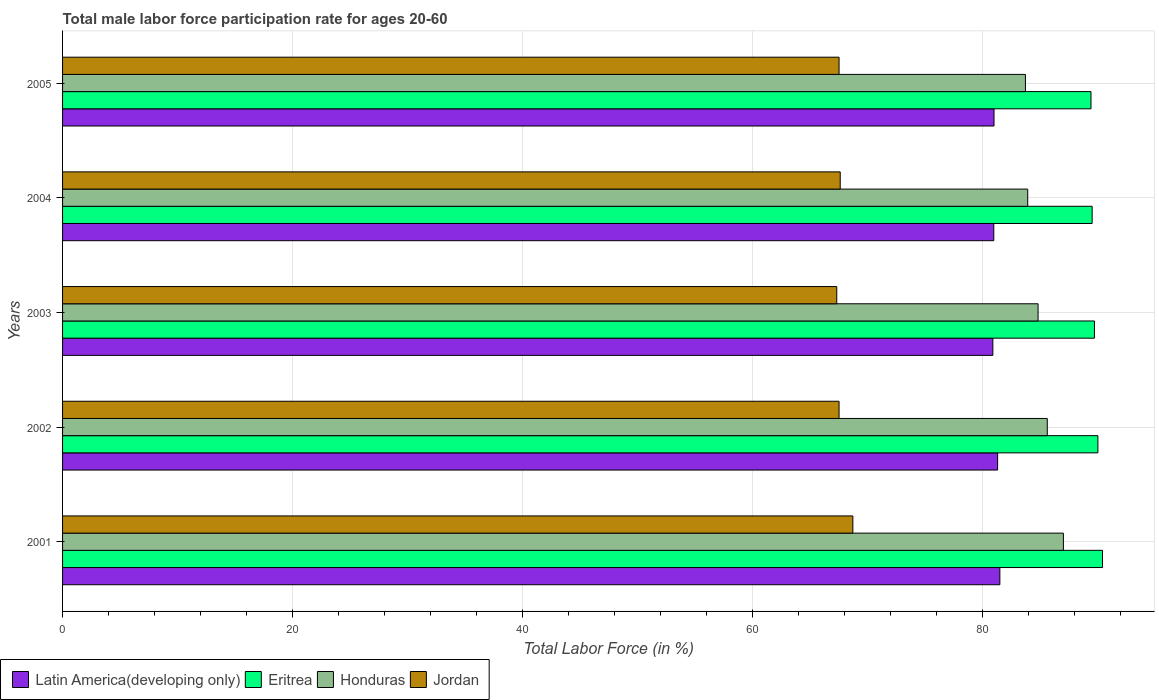How many different coloured bars are there?
Your answer should be compact. 4. How many bars are there on the 3rd tick from the top?
Make the answer very short. 4. How many bars are there on the 4th tick from the bottom?
Offer a very short reply. 4. What is the label of the 1st group of bars from the top?
Provide a succinct answer. 2005. In how many cases, is the number of bars for a given year not equal to the number of legend labels?
Offer a very short reply. 0. What is the male labor force participation rate in Eritrea in 2003?
Keep it short and to the point. 89.7. Across all years, what is the maximum male labor force participation rate in Latin America(developing only)?
Your answer should be very brief. 81.48. Across all years, what is the minimum male labor force participation rate in Latin America(developing only)?
Keep it short and to the point. 80.87. In which year was the male labor force participation rate in Jordan minimum?
Your response must be concise. 2003. What is the total male labor force participation rate in Eritrea in the graph?
Offer a very short reply. 449. What is the difference between the male labor force participation rate in Latin America(developing only) in 2001 and that in 2002?
Give a very brief answer. 0.19. What is the average male labor force participation rate in Honduras per year?
Provide a succinct answer. 85. In the year 2005, what is the difference between the male labor force participation rate in Eritrea and male labor force participation rate in Jordan?
Your response must be concise. 21.9. In how many years, is the male labor force participation rate in Eritrea greater than 64 %?
Give a very brief answer. 5. What is the ratio of the male labor force participation rate in Latin America(developing only) in 2001 to that in 2004?
Ensure brevity in your answer.  1.01. Is the male labor force participation rate in Eritrea in 2002 less than that in 2005?
Make the answer very short. No. Is the difference between the male labor force participation rate in Eritrea in 2002 and 2005 greater than the difference between the male labor force participation rate in Jordan in 2002 and 2005?
Give a very brief answer. Yes. What is the difference between the highest and the second highest male labor force participation rate in Latin America(developing only)?
Provide a short and direct response. 0.19. What is the difference between the highest and the lowest male labor force participation rate in Latin America(developing only)?
Ensure brevity in your answer.  0.61. In how many years, is the male labor force participation rate in Honduras greater than the average male labor force participation rate in Honduras taken over all years?
Your answer should be very brief. 2. Is the sum of the male labor force participation rate in Latin America(developing only) in 2001 and 2004 greater than the maximum male labor force participation rate in Eritrea across all years?
Ensure brevity in your answer.  Yes. Is it the case that in every year, the sum of the male labor force participation rate in Jordan and male labor force participation rate in Eritrea is greater than the sum of male labor force participation rate in Latin America(developing only) and male labor force participation rate in Honduras?
Your answer should be very brief. Yes. What does the 1st bar from the top in 2005 represents?
Offer a very short reply. Jordan. What does the 2nd bar from the bottom in 2004 represents?
Keep it short and to the point. Eritrea. Are all the bars in the graph horizontal?
Offer a terse response. Yes. What is the difference between two consecutive major ticks on the X-axis?
Ensure brevity in your answer.  20. Are the values on the major ticks of X-axis written in scientific E-notation?
Offer a very short reply. No. Where does the legend appear in the graph?
Provide a short and direct response. Bottom left. How many legend labels are there?
Your answer should be compact. 4. How are the legend labels stacked?
Give a very brief answer. Horizontal. What is the title of the graph?
Offer a very short reply. Total male labor force participation rate for ages 20-60. What is the Total Labor Force (in %) of Latin America(developing only) in 2001?
Keep it short and to the point. 81.48. What is the Total Labor Force (in %) in Eritrea in 2001?
Give a very brief answer. 90.4. What is the Total Labor Force (in %) in Honduras in 2001?
Your answer should be compact. 87. What is the Total Labor Force (in %) in Jordan in 2001?
Make the answer very short. 68.7. What is the Total Labor Force (in %) of Latin America(developing only) in 2002?
Make the answer very short. 81.28. What is the Total Labor Force (in %) in Honduras in 2002?
Make the answer very short. 85.6. What is the Total Labor Force (in %) of Jordan in 2002?
Make the answer very short. 67.5. What is the Total Labor Force (in %) of Latin America(developing only) in 2003?
Keep it short and to the point. 80.87. What is the Total Labor Force (in %) in Eritrea in 2003?
Your answer should be very brief. 89.7. What is the Total Labor Force (in %) in Honduras in 2003?
Offer a very short reply. 84.8. What is the Total Labor Force (in %) of Jordan in 2003?
Ensure brevity in your answer.  67.3. What is the Total Labor Force (in %) of Latin America(developing only) in 2004?
Offer a very short reply. 80.95. What is the Total Labor Force (in %) of Eritrea in 2004?
Keep it short and to the point. 89.5. What is the Total Labor Force (in %) of Honduras in 2004?
Give a very brief answer. 83.9. What is the Total Labor Force (in %) of Jordan in 2004?
Ensure brevity in your answer.  67.6. What is the Total Labor Force (in %) in Latin America(developing only) in 2005?
Give a very brief answer. 80.97. What is the Total Labor Force (in %) of Eritrea in 2005?
Your answer should be compact. 89.4. What is the Total Labor Force (in %) in Honduras in 2005?
Ensure brevity in your answer.  83.7. What is the Total Labor Force (in %) of Jordan in 2005?
Give a very brief answer. 67.5. Across all years, what is the maximum Total Labor Force (in %) in Latin America(developing only)?
Your answer should be compact. 81.48. Across all years, what is the maximum Total Labor Force (in %) in Eritrea?
Make the answer very short. 90.4. Across all years, what is the maximum Total Labor Force (in %) in Honduras?
Offer a very short reply. 87. Across all years, what is the maximum Total Labor Force (in %) of Jordan?
Make the answer very short. 68.7. Across all years, what is the minimum Total Labor Force (in %) of Latin America(developing only)?
Provide a short and direct response. 80.87. Across all years, what is the minimum Total Labor Force (in %) in Eritrea?
Give a very brief answer. 89.4. Across all years, what is the minimum Total Labor Force (in %) of Honduras?
Your answer should be very brief. 83.7. Across all years, what is the minimum Total Labor Force (in %) of Jordan?
Keep it short and to the point. 67.3. What is the total Total Labor Force (in %) of Latin America(developing only) in the graph?
Offer a terse response. 405.55. What is the total Total Labor Force (in %) in Eritrea in the graph?
Your answer should be compact. 449. What is the total Total Labor Force (in %) of Honduras in the graph?
Give a very brief answer. 425. What is the total Total Labor Force (in %) of Jordan in the graph?
Ensure brevity in your answer.  338.6. What is the difference between the Total Labor Force (in %) in Latin America(developing only) in 2001 and that in 2002?
Give a very brief answer. 0.19. What is the difference between the Total Labor Force (in %) in Honduras in 2001 and that in 2002?
Provide a succinct answer. 1.4. What is the difference between the Total Labor Force (in %) of Jordan in 2001 and that in 2002?
Ensure brevity in your answer.  1.2. What is the difference between the Total Labor Force (in %) of Latin America(developing only) in 2001 and that in 2003?
Offer a terse response. 0.61. What is the difference between the Total Labor Force (in %) of Eritrea in 2001 and that in 2003?
Keep it short and to the point. 0.7. What is the difference between the Total Labor Force (in %) of Jordan in 2001 and that in 2003?
Ensure brevity in your answer.  1.4. What is the difference between the Total Labor Force (in %) of Latin America(developing only) in 2001 and that in 2004?
Your answer should be compact. 0.53. What is the difference between the Total Labor Force (in %) in Honduras in 2001 and that in 2004?
Provide a succinct answer. 3.1. What is the difference between the Total Labor Force (in %) of Latin America(developing only) in 2001 and that in 2005?
Your answer should be very brief. 0.51. What is the difference between the Total Labor Force (in %) of Latin America(developing only) in 2002 and that in 2003?
Give a very brief answer. 0.41. What is the difference between the Total Labor Force (in %) of Latin America(developing only) in 2002 and that in 2004?
Ensure brevity in your answer.  0.33. What is the difference between the Total Labor Force (in %) of Eritrea in 2002 and that in 2004?
Provide a short and direct response. 0.5. What is the difference between the Total Labor Force (in %) of Jordan in 2002 and that in 2004?
Your answer should be very brief. -0.1. What is the difference between the Total Labor Force (in %) of Latin America(developing only) in 2002 and that in 2005?
Offer a terse response. 0.31. What is the difference between the Total Labor Force (in %) in Honduras in 2002 and that in 2005?
Provide a short and direct response. 1.9. What is the difference between the Total Labor Force (in %) of Latin America(developing only) in 2003 and that in 2004?
Offer a very short reply. -0.08. What is the difference between the Total Labor Force (in %) of Latin America(developing only) in 2003 and that in 2005?
Your response must be concise. -0.1. What is the difference between the Total Labor Force (in %) of Eritrea in 2003 and that in 2005?
Ensure brevity in your answer.  0.3. What is the difference between the Total Labor Force (in %) in Jordan in 2003 and that in 2005?
Your response must be concise. -0.2. What is the difference between the Total Labor Force (in %) of Latin America(developing only) in 2004 and that in 2005?
Give a very brief answer. -0.02. What is the difference between the Total Labor Force (in %) in Latin America(developing only) in 2001 and the Total Labor Force (in %) in Eritrea in 2002?
Your answer should be very brief. -8.52. What is the difference between the Total Labor Force (in %) in Latin America(developing only) in 2001 and the Total Labor Force (in %) in Honduras in 2002?
Provide a short and direct response. -4.12. What is the difference between the Total Labor Force (in %) of Latin America(developing only) in 2001 and the Total Labor Force (in %) of Jordan in 2002?
Ensure brevity in your answer.  13.98. What is the difference between the Total Labor Force (in %) of Eritrea in 2001 and the Total Labor Force (in %) of Honduras in 2002?
Make the answer very short. 4.8. What is the difference between the Total Labor Force (in %) of Eritrea in 2001 and the Total Labor Force (in %) of Jordan in 2002?
Your response must be concise. 22.9. What is the difference between the Total Labor Force (in %) of Honduras in 2001 and the Total Labor Force (in %) of Jordan in 2002?
Give a very brief answer. 19.5. What is the difference between the Total Labor Force (in %) in Latin America(developing only) in 2001 and the Total Labor Force (in %) in Eritrea in 2003?
Your response must be concise. -8.22. What is the difference between the Total Labor Force (in %) in Latin America(developing only) in 2001 and the Total Labor Force (in %) in Honduras in 2003?
Offer a terse response. -3.32. What is the difference between the Total Labor Force (in %) of Latin America(developing only) in 2001 and the Total Labor Force (in %) of Jordan in 2003?
Keep it short and to the point. 14.18. What is the difference between the Total Labor Force (in %) in Eritrea in 2001 and the Total Labor Force (in %) in Jordan in 2003?
Your answer should be compact. 23.1. What is the difference between the Total Labor Force (in %) of Latin America(developing only) in 2001 and the Total Labor Force (in %) of Eritrea in 2004?
Give a very brief answer. -8.02. What is the difference between the Total Labor Force (in %) in Latin America(developing only) in 2001 and the Total Labor Force (in %) in Honduras in 2004?
Make the answer very short. -2.42. What is the difference between the Total Labor Force (in %) in Latin America(developing only) in 2001 and the Total Labor Force (in %) in Jordan in 2004?
Your answer should be compact. 13.88. What is the difference between the Total Labor Force (in %) in Eritrea in 2001 and the Total Labor Force (in %) in Jordan in 2004?
Your answer should be compact. 22.8. What is the difference between the Total Labor Force (in %) of Honduras in 2001 and the Total Labor Force (in %) of Jordan in 2004?
Provide a short and direct response. 19.4. What is the difference between the Total Labor Force (in %) of Latin America(developing only) in 2001 and the Total Labor Force (in %) of Eritrea in 2005?
Offer a very short reply. -7.92. What is the difference between the Total Labor Force (in %) of Latin America(developing only) in 2001 and the Total Labor Force (in %) of Honduras in 2005?
Make the answer very short. -2.22. What is the difference between the Total Labor Force (in %) in Latin America(developing only) in 2001 and the Total Labor Force (in %) in Jordan in 2005?
Your answer should be compact. 13.98. What is the difference between the Total Labor Force (in %) in Eritrea in 2001 and the Total Labor Force (in %) in Honduras in 2005?
Ensure brevity in your answer.  6.7. What is the difference between the Total Labor Force (in %) in Eritrea in 2001 and the Total Labor Force (in %) in Jordan in 2005?
Offer a very short reply. 22.9. What is the difference between the Total Labor Force (in %) of Latin America(developing only) in 2002 and the Total Labor Force (in %) of Eritrea in 2003?
Give a very brief answer. -8.42. What is the difference between the Total Labor Force (in %) of Latin America(developing only) in 2002 and the Total Labor Force (in %) of Honduras in 2003?
Make the answer very short. -3.52. What is the difference between the Total Labor Force (in %) of Latin America(developing only) in 2002 and the Total Labor Force (in %) of Jordan in 2003?
Provide a short and direct response. 13.98. What is the difference between the Total Labor Force (in %) in Eritrea in 2002 and the Total Labor Force (in %) in Jordan in 2003?
Provide a succinct answer. 22.7. What is the difference between the Total Labor Force (in %) in Honduras in 2002 and the Total Labor Force (in %) in Jordan in 2003?
Your answer should be compact. 18.3. What is the difference between the Total Labor Force (in %) of Latin America(developing only) in 2002 and the Total Labor Force (in %) of Eritrea in 2004?
Provide a succinct answer. -8.22. What is the difference between the Total Labor Force (in %) in Latin America(developing only) in 2002 and the Total Labor Force (in %) in Honduras in 2004?
Your answer should be very brief. -2.62. What is the difference between the Total Labor Force (in %) of Latin America(developing only) in 2002 and the Total Labor Force (in %) of Jordan in 2004?
Your response must be concise. 13.68. What is the difference between the Total Labor Force (in %) in Eritrea in 2002 and the Total Labor Force (in %) in Jordan in 2004?
Keep it short and to the point. 22.4. What is the difference between the Total Labor Force (in %) of Latin America(developing only) in 2002 and the Total Labor Force (in %) of Eritrea in 2005?
Offer a very short reply. -8.12. What is the difference between the Total Labor Force (in %) of Latin America(developing only) in 2002 and the Total Labor Force (in %) of Honduras in 2005?
Offer a very short reply. -2.42. What is the difference between the Total Labor Force (in %) in Latin America(developing only) in 2002 and the Total Labor Force (in %) in Jordan in 2005?
Offer a terse response. 13.78. What is the difference between the Total Labor Force (in %) in Eritrea in 2002 and the Total Labor Force (in %) in Honduras in 2005?
Keep it short and to the point. 6.3. What is the difference between the Total Labor Force (in %) in Honduras in 2002 and the Total Labor Force (in %) in Jordan in 2005?
Your answer should be compact. 18.1. What is the difference between the Total Labor Force (in %) in Latin America(developing only) in 2003 and the Total Labor Force (in %) in Eritrea in 2004?
Your response must be concise. -8.63. What is the difference between the Total Labor Force (in %) in Latin America(developing only) in 2003 and the Total Labor Force (in %) in Honduras in 2004?
Your answer should be very brief. -3.03. What is the difference between the Total Labor Force (in %) in Latin America(developing only) in 2003 and the Total Labor Force (in %) in Jordan in 2004?
Ensure brevity in your answer.  13.27. What is the difference between the Total Labor Force (in %) of Eritrea in 2003 and the Total Labor Force (in %) of Jordan in 2004?
Offer a very short reply. 22.1. What is the difference between the Total Labor Force (in %) in Honduras in 2003 and the Total Labor Force (in %) in Jordan in 2004?
Your answer should be compact. 17.2. What is the difference between the Total Labor Force (in %) in Latin America(developing only) in 2003 and the Total Labor Force (in %) in Eritrea in 2005?
Your answer should be compact. -8.53. What is the difference between the Total Labor Force (in %) in Latin America(developing only) in 2003 and the Total Labor Force (in %) in Honduras in 2005?
Give a very brief answer. -2.83. What is the difference between the Total Labor Force (in %) in Latin America(developing only) in 2003 and the Total Labor Force (in %) in Jordan in 2005?
Give a very brief answer. 13.37. What is the difference between the Total Labor Force (in %) of Latin America(developing only) in 2004 and the Total Labor Force (in %) of Eritrea in 2005?
Your answer should be very brief. -8.45. What is the difference between the Total Labor Force (in %) in Latin America(developing only) in 2004 and the Total Labor Force (in %) in Honduras in 2005?
Keep it short and to the point. -2.75. What is the difference between the Total Labor Force (in %) of Latin America(developing only) in 2004 and the Total Labor Force (in %) of Jordan in 2005?
Your answer should be very brief. 13.45. What is the difference between the Total Labor Force (in %) in Eritrea in 2004 and the Total Labor Force (in %) in Jordan in 2005?
Ensure brevity in your answer.  22. What is the average Total Labor Force (in %) in Latin America(developing only) per year?
Offer a very short reply. 81.11. What is the average Total Labor Force (in %) in Eritrea per year?
Offer a terse response. 89.8. What is the average Total Labor Force (in %) in Jordan per year?
Make the answer very short. 67.72. In the year 2001, what is the difference between the Total Labor Force (in %) in Latin America(developing only) and Total Labor Force (in %) in Eritrea?
Ensure brevity in your answer.  -8.92. In the year 2001, what is the difference between the Total Labor Force (in %) of Latin America(developing only) and Total Labor Force (in %) of Honduras?
Provide a short and direct response. -5.52. In the year 2001, what is the difference between the Total Labor Force (in %) in Latin America(developing only) and Total Labor Force (in %) in Jordan?
Offer a terse response. 12.78. In the year 2001, what is the difference between the Total Labor Force (in %) of Eritrea and Total Labor Force (in %) of Jordan?
Give a very brief answer. 21.7. In the year 2002, what is the difference between the Total Labor Force (in %) of Latin America(developing only) and Total Labor Force (in %) of Eritrea?
Offer a terse response. -8.72. In the year 2002, what is the difference between the Total Labor Force (in %) of Latin America(developing only) and Total Labor Force (in %) of Honduras?
Keep it short and to the point. -4.32. In the year 2002, what is the difference between the Total Labor Force (in %) of Latin America(developing only) and Total Labor Force (in %) of Jordan?
Make the answer very short. 13.78. In the year 2002, what is the difference between the Total Labor Force (in %) in Eritrea and Total Labor Force (in %) in Honduras?
Your answer should be compact. 4.4. In the year 2002, what is the difference between the Total Labor Force (in %) in Eritrea and Total Labor Force (in %) in Jordan?
Ensure brevity in your answer.  22.5. In the year 2003, what is the difference between the Total Labor Force (in %) of Latin America(developing only) and Total Labor Force (in %) of Eritrea?
Keep it short and to the point. -8.83. In the year 2003, what is the difference between the Total Labor Force (in %) in Latin America(developing only) and Total Labor Force (in %) in Honduras?
Provide a succinct answer. -3.93. In the year 2003, what is the difference between the Total Labor Force (in %) of Latin America(developing only) and Total Labor Force (in %) of Jordan?
Keep it short and to the point. 13.57. In the year 2003, what is the difference between the Total Labor Force (in %) of Eritrea and Total Labor Force (in %) of Jordan?
Provide a succinct answer. 22.4. In the year 2003, what is the difference between the Total Labor Force (in %) of Honduras and Total Labor Force (in %) of Jordan?
Offer a terse response. 17.5. In the year 2004, what is the difference between the Total Labor Force (in %) in Latin America(developing only) and Total Labor Force (in %) in Eritrea?
Keep it short and to the point. -8.55. In the year 2004, what is the difference between the Total Labor Force (in %) of Latin America(developing only) and Total Labor Force (in %) of Honduras?
Ensure brevity in your answer.  -2.95. In the year 2004, what is the difference between the Total Labor Force (in %) of Latin America(developing only) and Total Labor Force (in %) of Jordan?
Offer a very short reply. 13.35. In the year 2004, what is the difference between the Total Labor Force (in %) in Eritrea and Total Labor Force (in %) in Jordan?
Offer a very short reply. 21.9. In the year 2005, what is the difference between the Total Labor Force (in %) of Latin America(developing only) and Total Labor Force (in %) of Eritrea?
Ensure brevity in your answer.  -8.43. In the year 2005, what is the difference between the Total Labor Force (in %) of Latin America(developing only) and Total Labor Force (in %) of Honduras?
Your response must be concise. -2.73. In the year 2005, what is the difference between the Total Labor Force (in %) in Latin America(developing only) and Total Labor Force (in %) in Jordan?
Offer a terse response. 13.47. In the year 2005, what is the difference between the Total Labor Force (in %) of Eritrea and Total Labor Force (in %) of Jordan?
Your response must be concise. 21.9. What is the ratio of the Total Labor Force (in %) of Latin America(developing only) in 2001 to that in 2002?
Give a very brief answer. 1. What is the ratio of the Total Labor Force (in %) in Honduras in 2001 to that in 2002?
Your answer should be compact. 1.02. What is the ratio of the Total Labor Force (in %) in Jordan in 2001 to that in 2002?
Offer a very short reply. 1.02. What is the ratio of the Total Labor Force (in %) in Latin America(developing only) in 2001 to that in 2003?
Your answer should be compact. 1.01. What is the ratio of the Total Labor Force (in %) of Eritrea in 2001 to that in 2003?
Provide a succinct answer. 1.01. What is the ratio of the Total Labor Force (in %) in Honduras in 2001 to that in 2003?
Make the answer very short. 1.03. What is the ratio of the Total Labor Force (in %) in Jordan in 2001 to that in 2003?
Provide a short and direct response. 1.02. What is the ratio of the Total Labor Force (in %) in Eritrea in 2001 to that in 2004?
Your answer should be compact. 1.01. What is the ratio of the Total Labor Force (in %) in Honduras in 2001 to that in 2004?
Your response must be concise. 1.04. What is the ratio of the Total Labor Force (in %) of Jordan in 2001 to that in 2004?
Your answer should be very brief. 1.02. What is the ratio of the Total Labor Force (in %) in Latin America(developing only) in 2001 to that in 2005?
Keep it short and to the point. 1.01. What is the ratio of the Total Labor Force (in %) in Eritrea in 2001 to that in 2005?
Make the answer very short. 1.01. What is the ratio of the Total Labor Force (in %) of Honduras in 2001 to that in 2005?
Your answer should be compact. 1.04. What is the ratio of the Total Labor Force (in %) of Jordan in 2001 to that in 2005?
Provide a short and direct response. 1.02. What is the ratio of the Total Labor Force (in %) of Latin America(developing only) in 2002 to that in 2003?
Your answer should be very brief. 1.01. What is the ratio of the Total Labor Force (in %) in Eritrea in 2002 to that in 2003?
Your response must be concise. 1. What is the ratio of the Total Labor Force (in %) in Honduras in 2002 to that in 2003?
Ensure brevity in your answer.  1.01. What is the ratio of the Total Labor Force (in %) in Jordan in 2002 to that in 2003?
Provide a succinct answer. 1. What is the ratio of the Total Labor Force (in %) in Latin America(developing only) in 2002 to that in 2004?
Make the answer very short. 1. What is the ratio of the Total Labor Force (in %) of Eritrea in 2002 to that in 2004?
Ensure brevity in your answer.  1.01. What is the ratio of the Total Labor Force (in %) in Honduras in 2002 to that in 2004?
Provide a succinct answer. 1.02. What is the ratio of the Total Labor Force (in %) of Honduras in 2002 to that in 2005?
Ensure brevity in your answer.  1.02. What is the ratio of the Total Labor Force (in %) of Eritrea in 2003 to that in 2004?
Your response must be concise. 1. What is the ratio of the Total Labor Force (in %) in Honduras in 2003 to that in 2004?
Offer a very short reply. 1.01. What is the ratio of the Total Labor Force (in %) of Jordan in 2003 to that in 2004?
Your answer should be very brief. 1. What is the ratio of the Total Labor Force (in %) of Latin America(developing only) in 2003 to that in 2005?
Offer a terse response. 1. What is the ratio of the Total Labor Force (in %) in Eritrea in 2003 to that in 2005?
Offer a terse response. 1. What is the ratio of the Total Labor Force (in %) of Honduras in 2003 to that in 2005?
Offer a very short reply. 1.01. What is the ratio of the Total Labor Force (in %) in Latin America(developing only) in 2004 to that in 2005?
Ensure brevity in your answer.  1. What is the ratio of the Total Labor Force (in %) in Jordan in 2004 to that in 2005?
Provide a succinct answer. 1. What is the difference between the highest and the second highest Total Labor Force (in %) in Latin America(developing only)?
Make the answer very short. 0.19. What is the difference between the highest and the second highest Total Labor Force (in %) in Honduras?
Provide a short and direct response. 1.4. What is the difference between the highest and the lowest Total Labor Force (in %) of Latin America(developing only)?
Make the answer very short. 0.61. What is the difference between the highest and the lowest Total Labor Force (in %) in Eritrea?
Provide a short and direct response. 1. What is the difference between the highest and the lowest Total Labor Force (in %) of Honduras?
Give a very brief answer. 3.3. What is the difference between the highest and the lowest Total Labor Force (in %) in Jordan?
Your answer should be very brief. 1.4. 